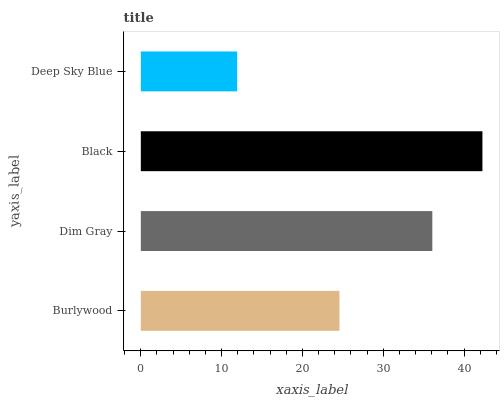Is Deep Sky Blue the minimum?
Answer yes or no. Yes. Is Black the maximum?
Answer yes or no. Yes. Is Dim Gray the minimum?
Answer yes or no. No. Is Dim Gray the maximum?
Answer yes or no. No. Is Dim Gray greater than Burlywood?
Answer yes or no. Yes. Is Burlywood less than Dim Gray?
Answer yes or no. Yes. Is Burlywood greater than Dim Gray?
Answer yes or no. No. Is Dim Gray less than Burlywood?
Answer yes or no. No. Is Dim Gray the high median?
Answer yes or no. Yes. Is Burlywood the low median?
Answer yes or no. Yes. Is Burlywood the high median?
Answer yes or no. No. Is Dim Gray the low median?
Answer yes or no. No. 